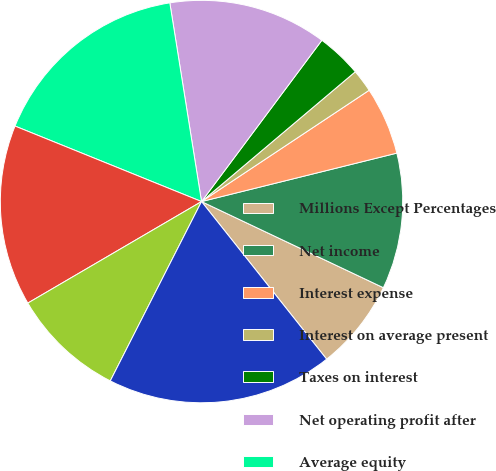Convert chart. <chart><loc_0><loc_0><loc_500><loc_500><pie_chart><fcel>Millions Except Percentages<fcel>Net income<fcel>Interest expense<fcel>Interest on average present<fcel>Taxes on interest<fcel>Net operating profit after<fcel>Average equity<fcel>Average debt<fcel>Average present value of<fcel>Average invested capital as<nl><fcel>7.28%<fcel>10.91%<fcel>5.46%<fcel>1.83%<fcel>3.64%<fcel>12.72%<fcel>16.36%<fcel>14.54%<fcel>9.09%<fcel>18.17%<nl></chart> 